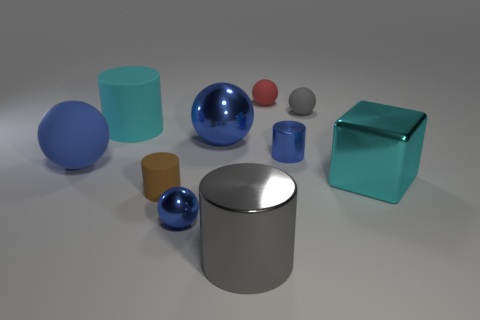Subtract all blue balls. How many were subtracted if there are1blue balls left? 2 Subtract all brown matte cylinders. How many cylinders are left? 3 Subtract all gray cylinders. How many cylinders are left? 3 Subtract 1 blocks. How many blocks are left? 0 Subtract all shiny objects. Subtract all cyan matte objects. How many objects are left? 4 Add 5 large blue matte objects. How many large blue matte objects are left? 6 Add 8 large red rubber objects. How many large red rubber objects exist? 8 Subtract 1 blue cylinders. How many objects are left? 9 Subtract all cylinders. How many objects are left? 6 Subtract all brown cubes. Subtract all red balls. How many cubes are left? 1 